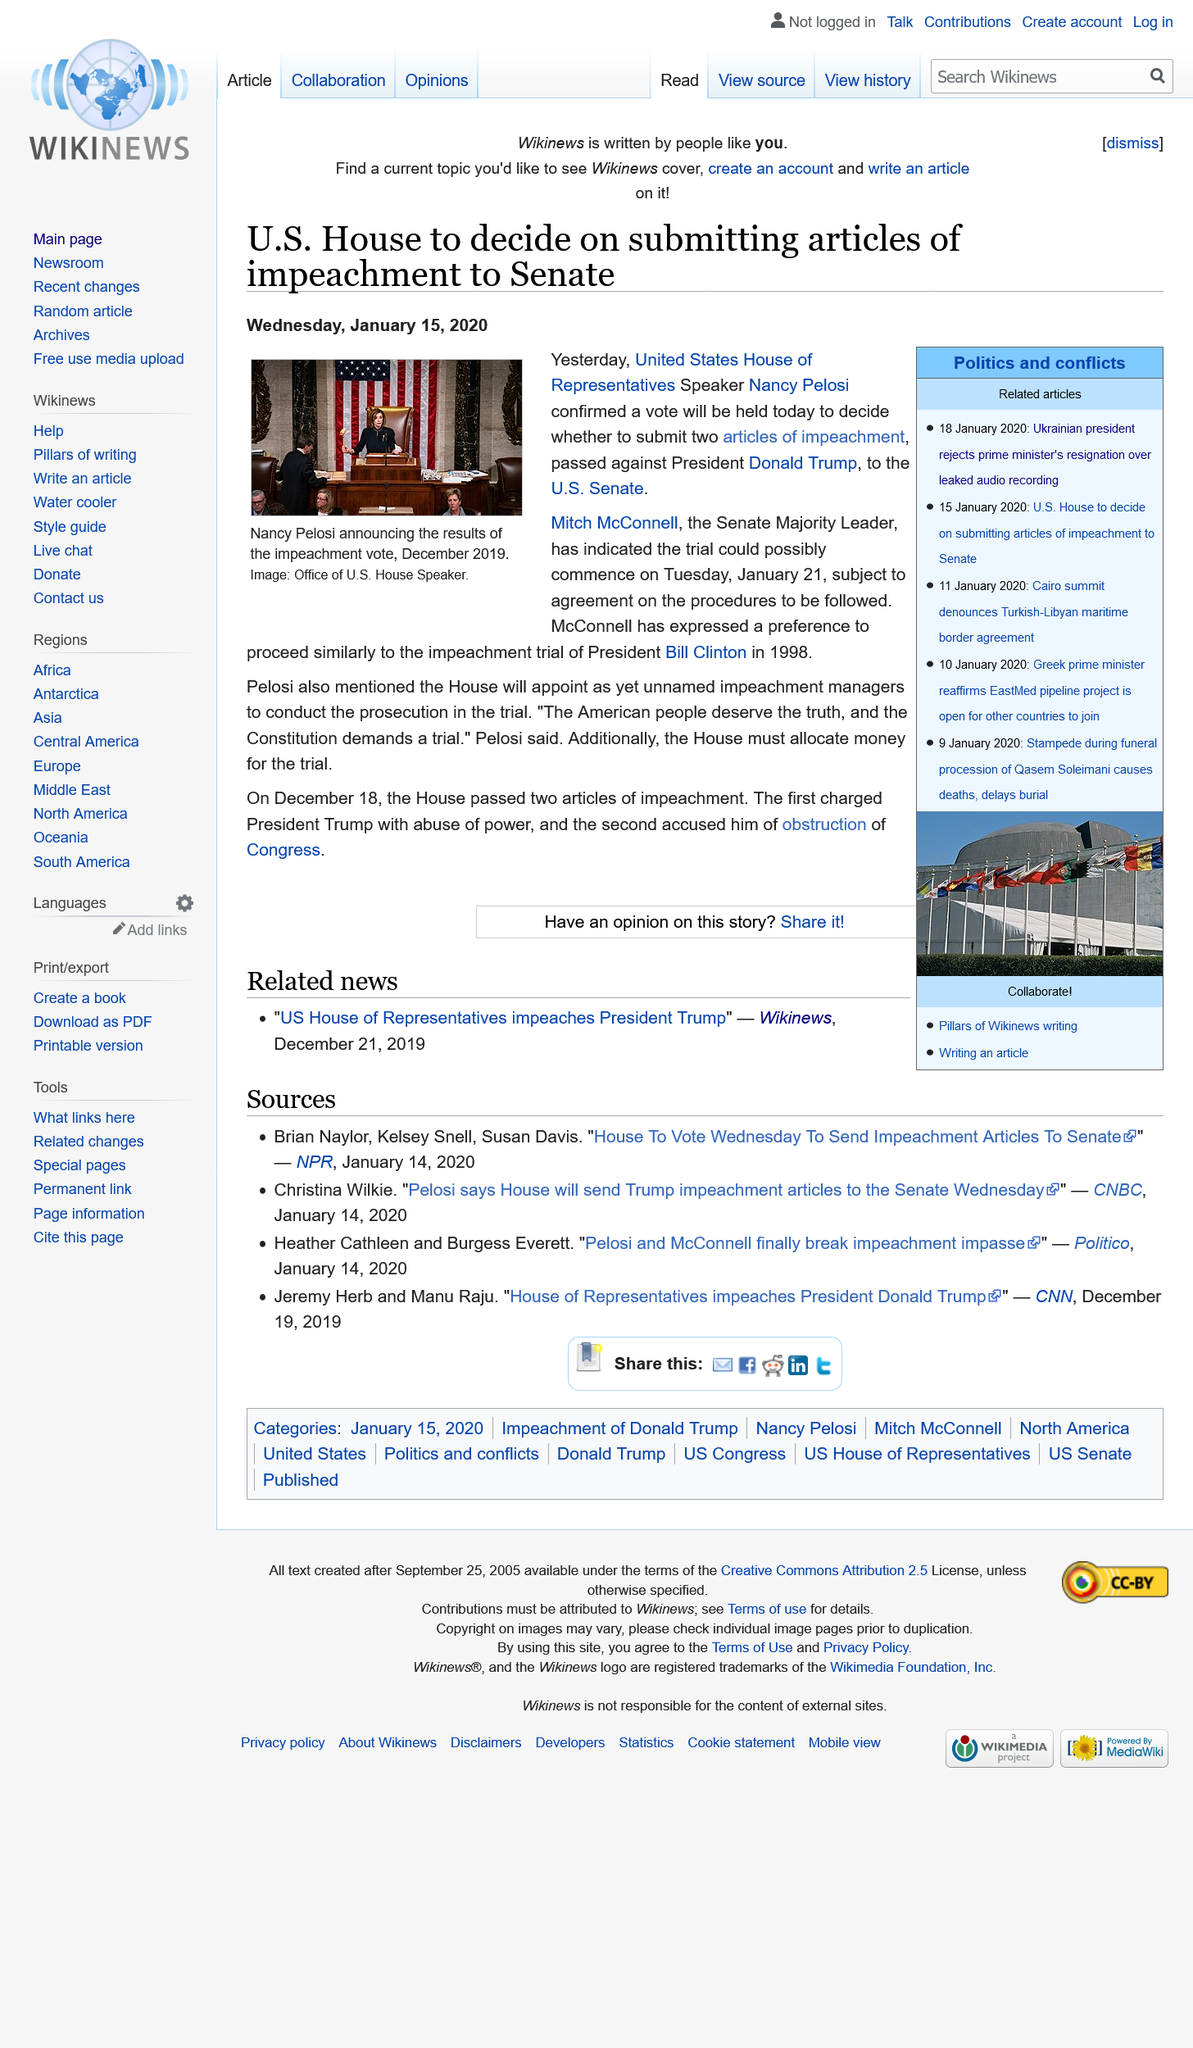Indicate a few pertinent items in this graphic. The article was published on Wednesday, January 15, 2020. On Tuesday, January 21, the impeachment trial against President Donald Trump is scheduled to commence. During the impeachment trial of President Bill Clinton in 1998, Senate Majority Leader Mitch McConnell suggested following the same procedures as the previous impeachment trial of President Andrew Johnson in 1868. 